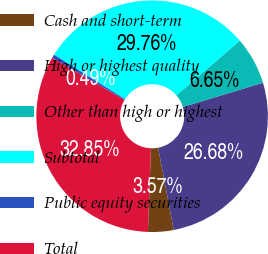Convert chart to OTSL. <chart><loc_0><loc_0><loc_500><loc_500><pie_chart><fcel>Cash and short-term<fcel>High or highest quality<fcel>Other than high or highest<fcel>Subtotal<fcel>Public equity securities<fcel>Total<nl><fcel>3.57%<fcel>26.68%<fcel>6.65%<fcel>29.76%<fcel>0.49%<fcel>32.85%<nl></chart> 